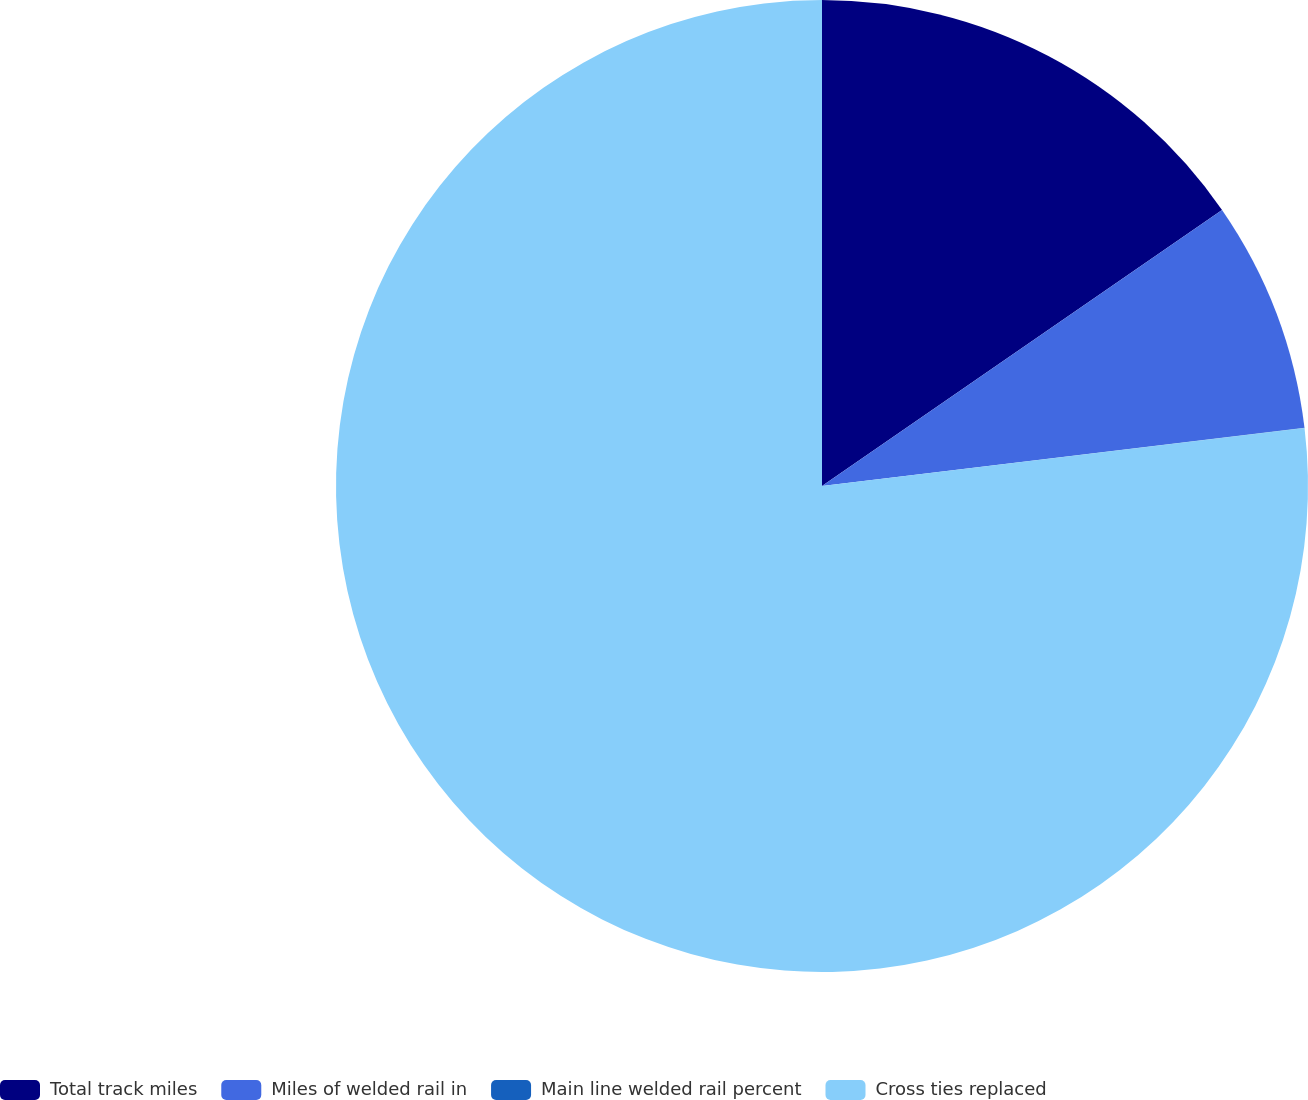Convert chart to OTSL. <chart><loc_0><loc_0><loc_500><loc_500><pie_chart><fcel>Total track miles<fcel>Miles of welded rail in<fcel>Main line welded rail percent<fcel>Cross ties replaced<nl><fcel>15.39%<fcel>7.7%<fcel>0.01%<fcel>76.91%<nl></chart> 